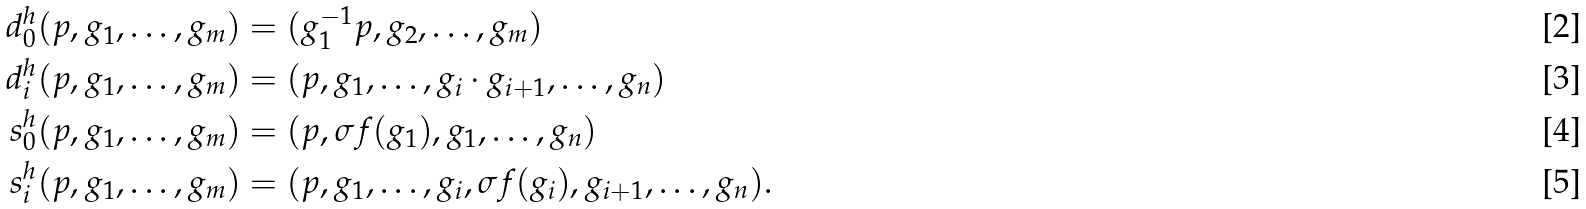Convert formula to latex. <formula><loc_0><loc_0><loc_500><loc_500>d ^ { h } _ { 0 } ( p , g _ { 1 } , \dots , g _ { m } ) & = ( g _ { 1 } ^ { - 1 } p , g _ { 2 } , \dots , g _ { m } ) \\ d ^ { h } _ { i } ( p , g _ { 1 } , \dots , g _ { m } ) & = ( p , g _ { 1 } , \dots , g _ { i } \cdot g _ { i + 1 } , \dots , g _ { n } ) \\ s ^ { h } _ { 0 } ( p , g _ { 1 } , \dots , g _ { m } ) & = ( p , \sigma f ( g _ { 1 } ) , g _ { 1 } , \dots , g _ { n } ) \\ s ^ { h } _ { i } ( p , g _ { 1 } , \dots , g _ { m } ) & = ( p , g _ { 1 } , \dots , g _ { i } , \sigma f ( g _ { i } ) , g _ { i + 1 } , \dots , g _ { n } ) .</formula> 